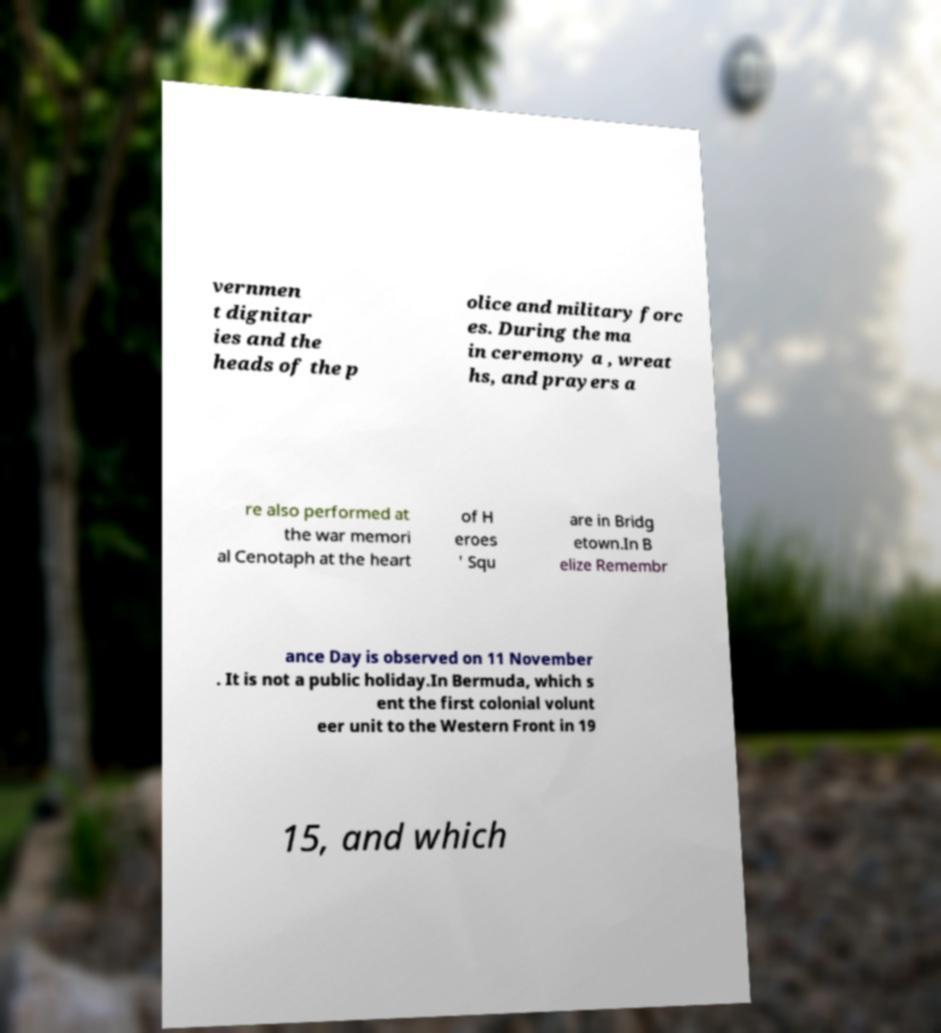What messages or text are displayed in this image? I need them in a readable, typed format. vernmen t dignitar ies and the heads of the p olice and military forc es. During the ma in ceremony a , wreat hs, and prayers a re also performed at the war memori al Cenotaph at the heart of H eroes ' Squ are in Bridg etown.In B elize Remembr ance Day is observed on 11 November . It is not a public holiday.In Bermuda, which s ent the first colonial volunt eer unit to the Western Front in 19 15, and which 